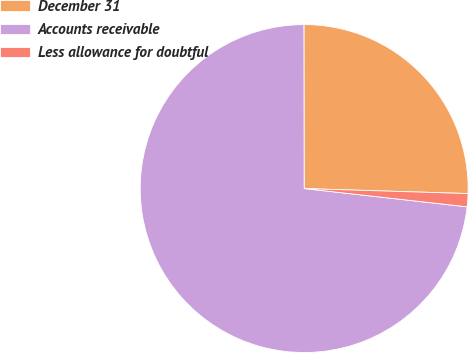<chart> <loc_0><loc_0><loc_500><loc_500><pie_chart><fcel>December 31<fcel>Accounts receivable<fcel>Less allowance for doubtful<nl><fcel>25.51%<fcel>73.2%<fcel>1.29%<nl></chart> 